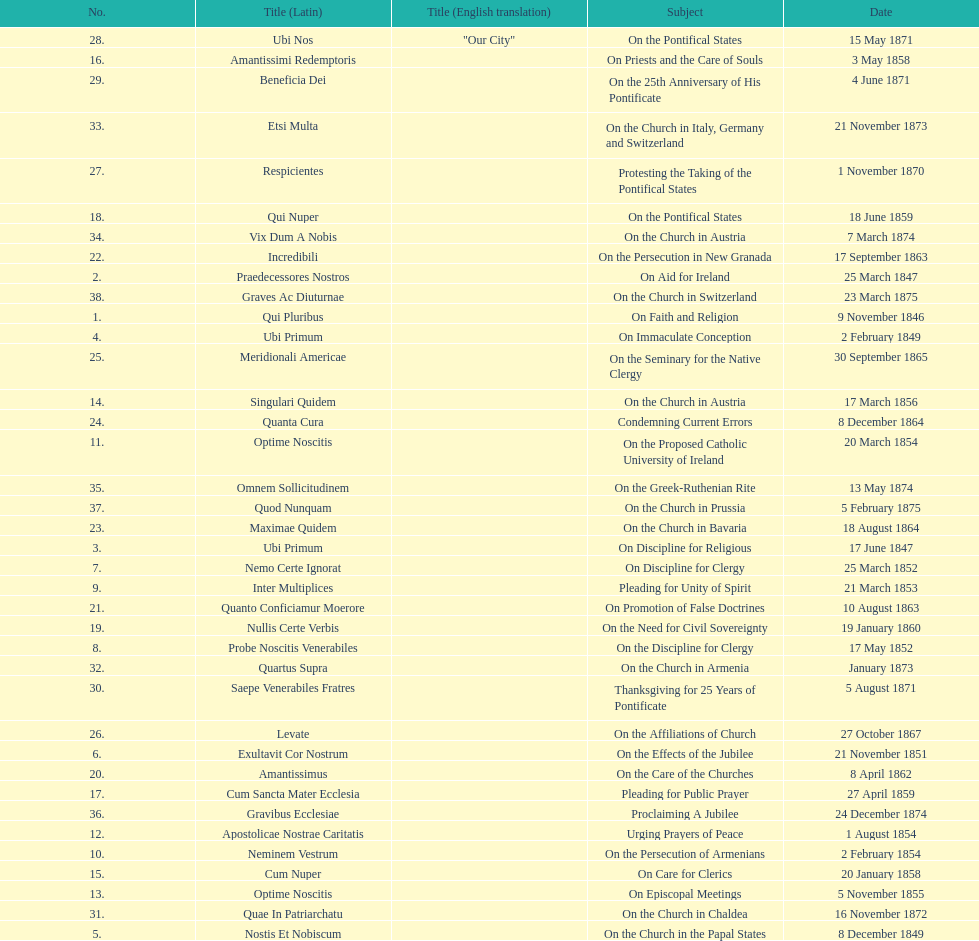Would you be able to parse every entry in this table? {'header': ['No.', 'Title (Latin)', 'Title (English translation)', 'Subject', 'Date'], 'rows': [['28.', 'Ubi Nos', '"Our City"', 'On the Pontifical States', '15 May 1871'], ['16.', 'Amantissimi Redemptoris', '', 'On Priests and the Care of Souls', '3 May 1858'], ['29.', 'Beneficia Dei', '', 'On the 25th Anniversary of His Pontificate', '4 June 1871'], ['33.', 'Etsi Multa', '', 'On the Church in Italy, Germany and Switzerland', '21 November 1873'], ['27.', 'Respicientes', '', 'Protesting the Taking of the Pontifical States', '1 November 1870'], ['18.', 'Qui Nuper', '', 'On the Pontifical States', '18 June 1859'], ['34.', 'Vix Dum A Nobis', '', 'On the Church in Austria', '7 March 1874'], ['22.', 'Incredibili', '', 'On the Persecution in New Granada', '17 September 1863'], ['2.', 'Praedecessores Nostros', '', 'On Aid for Ireland', '25 March 1847'], ['38.', 'Graves Ac Diuturnae', '', 'On the Church in Switzerland', '23 March 1875'], ['1.', 'Qui Pluribus', '', 'On Faith and Religion', '9 November 1846'], ['4.', 'Ubi Primum', '', 'On Immaculate Conception', '2 February 1849'], ['25.', 'Meridionali Americae', '', 'On the Seminary for the Native Clergy', '30 September 1865'], ['14.', 'Singulari Quidem', '', 'On the Church in Austria', '17 March 1856'], ['24.', 'Quanta Cura', '', 'Condemning Current Errors', '8 December 1864'], ['11.', 'Optime Noscitis', '', 'On the Proposed Catholic University of Ireland', '20 March 1854'], ['35.', 'Omnem Sollicitudinem', '', 'On the Greek-Ruthenian Rite', '13 May 1874'], ['37.', 'Quod Nunquam', '', 'On the Church in Prussia', '5 February 1875'], ['23.', 'Maximae Quidem', '', 'On the Church in Bavaria', '18 August 1864'], ['3.', 'Ubi Primum', '', 'On Discipline for Religious', '17 June 1847'], ['7.', 'Nemo Certe Ignorat', '', 'On Discipline for Clergy', '25 March 1852'], ['9.', 'Inter Multiplices', '', 'Pleading for Unity of Spirit', '21 March 1853'], ['21.', 'Quanto Conficiamur Moerore', '', 'On Promotion of False Doctrines', '10 August 1863'], ['19.', 'Nullis Certe Verbis', '', 'On the Need for Civil Sovereignty', '19 January 1860'], ['8.', 'Probe Noscitis Venerabiles', '', 'On the Discipline for Clergy', '17 May 1852'], ['32.', 'Quartus Supra', '', 'On the Church in Armenia', 'January 1873'], ['30.', 'Saepe Venerabiles Fratres', '', 'Thanksgiving for 25 Years of Pontificate', '5 August 1871'], ['26.', 'Levate', '', 'On the Affiliations of Church', '27 October 1867'], ['6.', 'Exultavit Cor Nostrum', '', 'On the Effects of the Jubilee', '21 November 1851'], ['20.', 'Amantissimus', '', 'On the Care of the Churches', '8 April 1862'], ['17.', 'Cum Sancta Mater Ecclesia', '', 'Pleading for Public Prayer', '27 April 1859'], ['36.', 'Gravibus Ecclesiae', '', 'Proclaiming A Jubilee', '24 December 1874'], ['12.', 'Apostolicae Nostrae Caritatis', '', 'Urging Prayers of Peace', '1 August 1854'], ['10.', 'Neminem Vestrum', '', 'On the Persecution of Armenians', '2 February 1854'], ['15.', 'Cum Nuper', '', 'On Care for Clerics', '20 January 1858'], ['13.', 'Optime Noscitis', '', 'On Episcopal Meetings', '5 November 1855'], ['31.', 'Quae In Patriarchatu', '', 'On the Church in Chaldea', '16 November 1872'], ['5.', 'Nostis Et Nobiscum', '', 'On the Church in the Papal States', '8 December 1849']]} What is the last title? Graves Ac Diuturnae. 